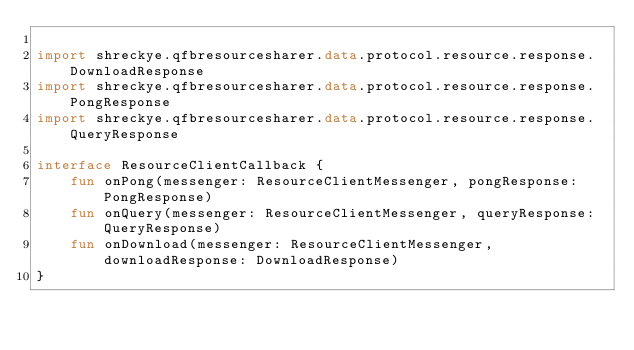<code> <loc_0><loc_0><loc_500><loc_500><_Kotlin_>
import shreckye.qfbresourcesharer.data.protocol.resource.response.DownloadResponse
import shreckye.qfbresourcesharer.data.protocol.resource.response.PongResponse
import shreckye.qfbresourcesharer.data.protocol.resource.response.QueryResponse

interface ResourceClientCallback {
    fun onPong(messenger: ResourceClientMessenger, pongResponse: PongResponse)
    fun onQuery(messenger: ResourceClientMessenger, queryResponse: QueryResponse)
    fun onDownload(messenger: ResourceClientMessenger, downloadResponse: DownloadResponse)
}</code> 